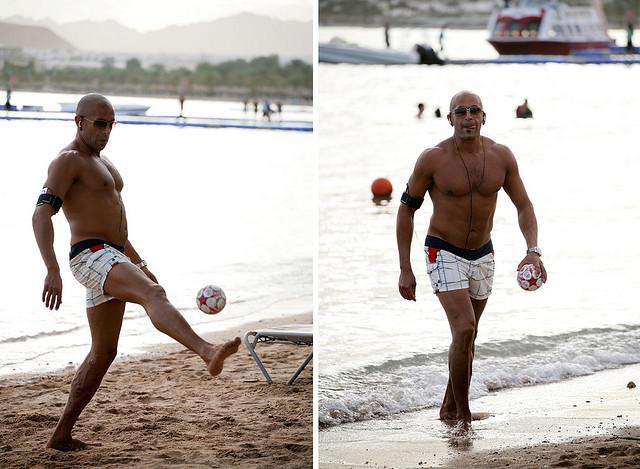Is the water in this photo calm?
Quick response, please. Yes. What colors are the ball?
Keep it brief. Red and white. Does this man look fit?
Write a very short answer. Yes. 